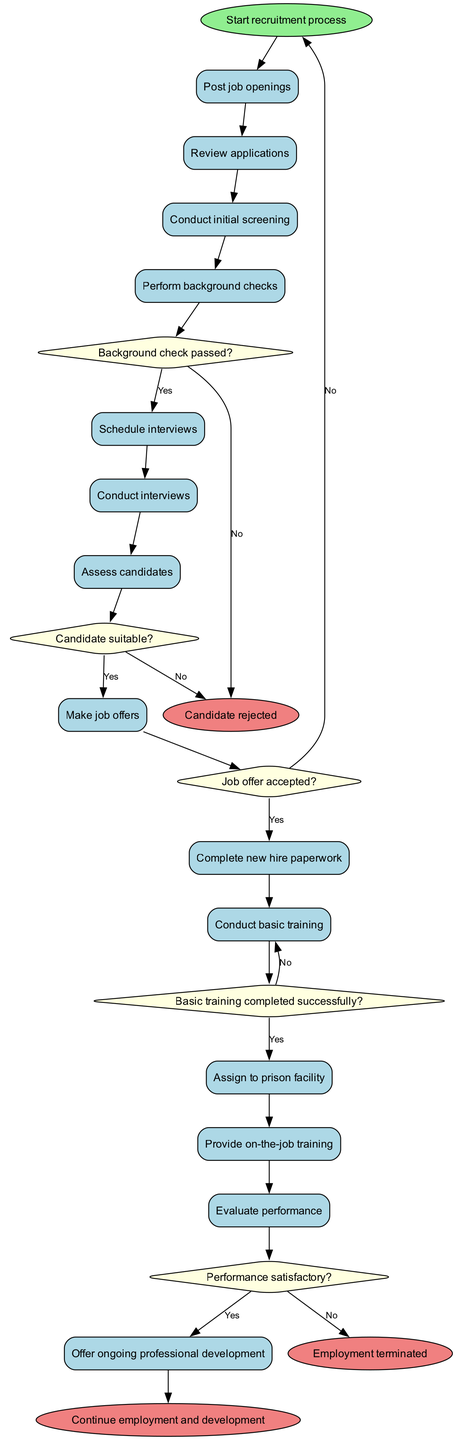What is the initial node of the diagram? The initial node is "Start recruitment process," which indicates the beginning of the flow in the diagram.
Answer: Start recruitment process How many activities are included in the process? The diagram lists 13 distinct activities, starting from posting job openings to offering ongoing professional development.
Answer: 13 What happens after the "Perform background checks" activity? The flow moves to a decision point labeled "Background check passed?" where it determines if the candidate passes the background checks to proceed or not.
Answer: Background check passed? What is the end node that signifies candidate rejection? The end node for candidate rejection is labeled "Candidate rejected," indicating an unsuccessful outcome in the recruitment process.
Answer: Candidate rejected If a job offer is accepted, which activity follows? If the job offer is accepted, the next activity labeled is "Complete new hire paperwork," signifying the transition from offer acceptance to formal employment procedures.
Answer: Complete new hire paperwork What action is taken if the basic training is not completed successfully? If basic training is not completed successfully, the flow returns to "Conduct basic training," indicating that a candidate must retry the training.
Answer: Conduct basic training What is the decision point after "Evaluate performance"? After "Evaluate performance," the decision point is labeled "Performance satisfactory?" which determines if the staff member continues in their role.
Answer: Performance satisfactory? What do you recommend if a candidate requires additional support after training? The process indicates to "Provide additional support," suggesting a continued development approach for the individual.
Answer: Provide additional support What is the outcome if all criteria are satisfied after "Evaluate performance"? If all criteria are satisfied, the flow proceeds to "Continue employment and development," indicating a successful outcome in the recruitment and development process.
Answer: Continue employment and development 